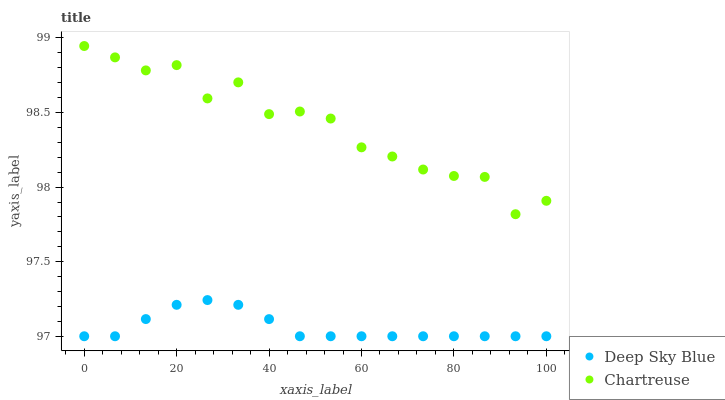Does Deep Sky Blue have the minimum area under the curve?
Answer yes or no. Yes. Does Chartreuse have the maximum area under the curve?
Answer yes or no. Yes. Does Deep Sky Blue have the maximum area under the curve?
Answer yes or no. No. Is Deep Sky Blue the smoothest?
Answer yes or no. Yes. Is Chartreuse the roughest?
Answer yes or no. Yes. Is Deep Sky Blue the roughest?
Answer yes or no. No. Does Deep Sky Blue have the lowest value?
Answer yes or no. Yes. Does Chartreuse have the highest value?
Answer yes or no. Yes. Does Deep Sky Blue have the highest value?
Answer yes or no. No. Is Deep Sky Blue less than Chartreuse?
Answer yes or no. Yes. Is Chartreuse greater than Deep Sky Blue?
Answer yes or no. Yes. Does Deep Sky Blue intersect Chartreuse?
Answer yes or no. No. 